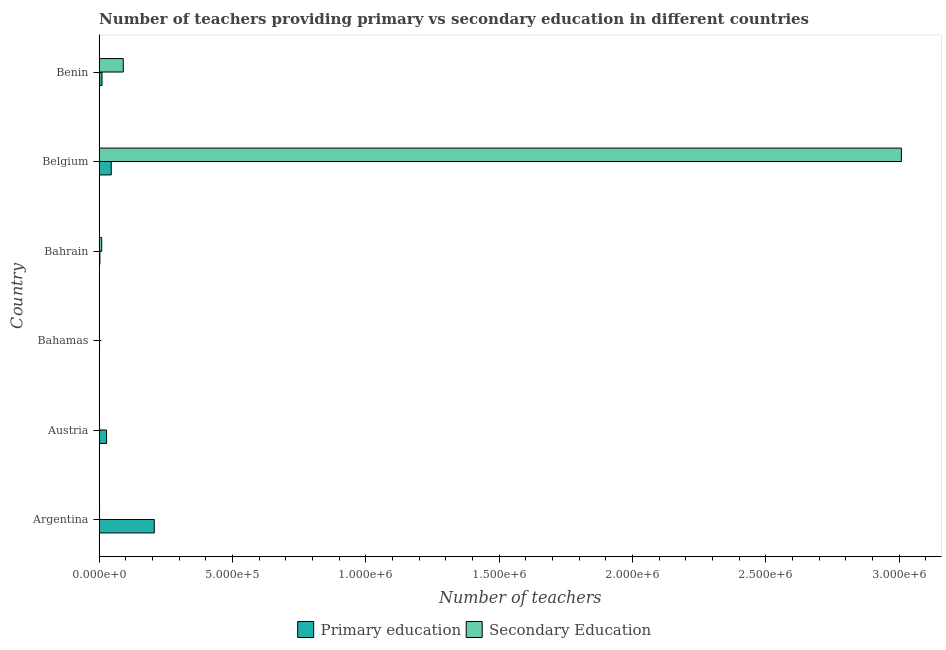How many different coloured bars are there?
Make the answer very short. 2. How many bars are there on the 2nd tick from the top?
Keep it short and to the point. 2. In how many cases, is the number of bars for a given country not equal to the number of legend labels?
Keep it short and to the point. 0. What is the number of secondary teachers in Bahrain?
Make the answer very short. 9335. Across all countries, what is the maximum number of primary teachers?
Keep it short and to the point. 2.07e+05. Across all countries, what is the minimum number of secondary teachers?
Your response must be concise. 210. In which country was the number of primary teachers maximum?
Ensure brevity in your answer.  Argentina. In which country was the number of secondary teachers minimum?
Your answer should be compact. Bahamas. What is the total number of primary teachers in the graph?
Ensure brevity in your answer.  2.93e+05. What is the difference between the number of primary teachers in Argentina and that in Bahamas?
Give a very brief answer. 2.05e+05. What is the difference between the number of secondary teachers in Argentina and the number of primary teachers in Bahrain?
Offer a terse response. -1312. What is the average number of secondary teachers per country?
Your answer should be compact. 5.18e+05. What is the difference between the number of secondary teachers and number of primary teachers in Argentina?
Give a very brief answer. -2.05e+05. What is the ratio of the number of primary teachers in Argentina to that in Bahamas?
Ensure brevity in your answer.  179.44. Is the difference between the number of secondary teachers in Bahamas and Bahrain greater than the difference between the number of primary teachers in Bahamas and Bahrain?
Make the answer very short. No. What is the difference between the highest and the second highest number of secondary teachers?
Your answer should be compact. 2.92e+06. What is the difference between the highest and the lowest number of primary teachers?
Ensure brevity in your answer.  2.05e+05. In how many countries, is the number of primary teachers greater than the average number of primary teachers taken over all countries?
Provide a short and direct response. 1. Is the sum of the number of secondary teachers in Austria and Benin greater than the maximum number of primary teachers across all countries?
Your response must be concise. No. What does the 1st bar from the top in Bahamas represents?
Provide a succinct answer. Secondary Education. How many bars are there?
Keep it short and to the point. 12. Are all the bars in the graph horizontal?
Provide a short and direct response. Yes. How many countries are there in the graph?
Offer a terse response. 6. What is the difference between two consecutive major ticks on the X-axis?
Your answer should be very brief. 5.00e+05. Does the graph contain any zero values?
Offer a terse response. No. Does the graph contain grids?
Your response must be concise. No. How are the legend labels stacked?
Your response must be concise. Horizontal. What is the title of the graph?
Give a very brief answer. Number of teachers providing primary vs secondary education in different countries. Does "Foreign Liabilities" appear as one of the legend labels in the graph?
Offer a terse response. No. What is the label or title of the X-axis?
Ensure brevity in your answer.  Number of teachers. What is the label or title of the Y-axis?
Keep it short and to the point. Country. What is the Number of teachers of Primary education in Argentina?
Make the answer very short. 2.07e+05. What is the Number of teachers in Secondary Education in Argentina?
Give a very brief answer. 1231. What is the Number of teachers of Primary education in Austria?
Your answer should be very brief. 2.76e+04. What is the Number of teachers in Secondary Education in Austria?
Make the answer very short. 1155. What is the Number of teachers in Primary education in Bahamas?
Provide a succinct answer. 1151. What is the Number of teachers in Secondary Education in Bahamas?
Your answer should be compact. 210. What is the Number of teachers in Primary education in Bahrain?
Offer a very short reply. 2543. What is the Number of teachers of Secondary Education in Bahrain?
Provide a succinct answer. 9335. What is the Number of teachers of Primary education in Belgium?
Keep it short and to the point. 4.51e+04. What is the Number of teachers in Secondary Education in Belgium?
Provide a succinct answer. 3.01e+06. What is the Number of teachers of Primary education in Benin?
Provide a succinct answer. 1.04e+04. What is the Number of teachers of Secondary Education in Benin?
Provide a succinct answer. 9.02e+04. Across all countries, what is the maximum Number of teachers of Primary education?
Keep it short and to the point. 2.07e+05. Across all countries, what is the maximum Number of teachers in Secondary Education?
Your answer should be compact. 3.01e+06. Across all countries, what is the minimum Number of teachers of Primary education?
Your response must be concise. 1151. Across all countries, what is the minimum Number of teachers in Secondary Education?
Your answer should be very brief. 210. What is the total Number of teachers of Primary education in the graph?
Keep it short and to the point. 2.93e+05. What is the total Number of teachers of Secondary Education in the graph?
Provide a short and direct response. 3.11e+06. What is the difference between the Number of teachers of Primary education in Argentina and that in Austria?
Your answer should be very brief. 1.79e+05. What is the difference between the Number of teachers in Primary education in Argentina and that in Bahamas?
Provide a succinct answer. 2.05e+05. What is the difference between the Number of teachers of Secondary Education in Argentina and that in Bahamas?
Your response must be concise. 1021. What is the difference between the Number of teachers in Primary education in Argentina and that in Bahrain?
Keep it short and to the point. 2.04e+05. What is the difference between the Number of teachers in Secondary Education in Argentina and that in Bahrain?
Make the answer very short. -8104. What is the difference between the Number of teachers in Primary education in Argentina and that in Belgium?
Offer a very short reply. 1.61e+05. What is the difference between the Number of teachers in Secondary Education in Argentina and that in Belgium?
Keep it short and to the point. -3.01e+06. What is the difference between the Number of teachers in Primary education in Argentina and that in Benin?
Your answer should be very brief. 1.96e+05. What is the difference between the Number of teachers in Secondary Education in Argentina and that in Benin?
Offer a very short reply. -8.89e+04. What is the difference between the Number of teachers in Primary education in Austria and that in Bahamas?
Provide a short and direct response. 2.64e+04. What is the difference between the Number of teachers of Secondary Education in Austria and that in Bahamas?
Offer a terse response. 945. What is the difference between the Number of teachers of Primary education in Austria and that in Bahrain?
Your answer should be compact. 2.50e+04. What is the difference between the Number of teachers of Secondary Education in Austria and that in Bahrain?
Ensure brevity in your answer.  -8180. What is the difference between the Number of teachers of Primary education in Austria and that in Belgium?
Your answer should be very brief. -1.76e+04. What is the difference between the Number of teachers in Secondary Education in Austria and that in Belgium?
Provide a short and direct response. -3.01e+06. What is the difference between the Number of teachers in Primary education in Austria and that in Benin?
Your response must be concise. 1.72e+04. What is the difference between the Number of teachers of Secondary Education in Austria and that in Benin?
Your answer should be very brief. -8.90e+04. What is the difference between the Number of teachers of Primary education in Bahamas and that in Bahrain?
Ensure brevity in your answer.  -1392. What is the difference between the Number of teachers of Secondary Education in Bahamas and that in Bahrain?
Offer a terse response. -9125. What is the difference between the Number of teachers in Primary education in Bahamas and that in Belgium?
Your answer should be compact. -4.40e+04. What is the difference between the Number of teachers in Secondary Education in Bahamas and that in Belgium?
Provide a succinct answer. -3.01e+06. What is the difference between the Number of teachers of Primary education in Bahamas and that in Benin?
Provide a short and direct response. -9230. What is the difference between the Number of teachers of Secondary Education in Bahamas and that in Benin?
Make the answer very short. -9.00e+04. What is the difference between the Number of teachers in Primary education in Bahrain and that in Belgium?
Give a very brief answer. -4.26e+04. What is the difference between the Number of teachers of Secondary Education in Bahrain and that in Belgium?
Make the answer very short. -3.00e+06. What is the difference between the Number of teachers of Primary education in Bahrain and that in Benin?
Give a very brief answer. -7838. What is the difference between the Number of teachers of Secondary Education in Bahrain and that in Benin?
Give a very brief answer. -8.08e+04. What is the difference between the Number of teachers in Primary education in Belgium and that in Benin?
Your response must be concise. 3.47e+04. What is the difference between the Number of teachers in Secondary Education in Belgium and that in Benin?
Your answer should be compact. 2.92e+06. What is the difference between the Number of teachers of Primary education in Argentina and the Number of teachers of Secondary Education in Austria?
Give a very brief answer. 2.05e+05. What is the difference between the Number of teachers in Primary education in Argentina and the Number of teachers in Secondary Education in Bahamas?
Your answer should be compact. 2.06e+05. What is the difference between the Number of teachers of Primary education in Argentina and the Number of teachers of Secondary Education in Bahrain?
Keep it short and to the point. 1.97e+05. What is the difference between the Number of teachers in Primary education in Argentina and the Number of teachers in Secondary Education in Belgium?
Make the answer very short. -2.80e+06. What is the difference between the Number of teachers of Primary education in Argentina and the Number of teachers of Secondary Education in Benin?
Provide a succinct answer. 1.16e+05. What is the difference between the Number of teachers in Primary education in Austria and the Number of teachers in Secondary Education in Bahamas?
Your answer should be very brief. 2.74e+04. What is the difference between the Number of teachers of Primary education in Austria and the Number of teachers of Secondary Education in Bahrain?
Offer a very short reply. 1.82e+04. What is the difference between the Number of teachers of Primary education in Austria and the Number of teachers of Secondary Education in Belgium?
Offer a very short reply. -2.98e+06. What is the difference between the Number of teachers in Primary education in Austria and the Number of teachers in Secondary Education in Benin?
Make the answer very short. -6.26e+04. What is the difference between the Number of teachers of Primary education in Bahamas and the Number of teachers of Secondary Education in Bahrain?
Your answer should be compact. -8184. What is the difference between the Number of teachers of Primary education in Bahamas and the Number of teachers of Secondary Education in Belgium?
Make the answer very short. -3.01e+06. What is the difference between the Number of teachers of Primary education in Bahamas and the Number of teachers of Secondary Education in Benin?
Your answer should be compact. -8.90e+04. What is the difference between the Number of teachers in Primary education in Bahrain and the Number of teachers in Secondary Education in Belgium?
Offer a very short reply. -3.01e+06. What is the difference between the Number of teachers in Primary education in Bahrain and the Number of teachers in Secondary Education in Benin?
Make the answer very short. -8.76e+04. What is the difference between the Number of teachers of Primary education in Belgium and the Number of teachers of Secondary Education in Benin?
Your response must be concise. -4.50e+04. What is the average Number of teachers of Primary education per country?
Ensure brevity in your answer.  4.89e+04. What is the average Number of teachers of Secondary Education per country?
Offer a terse response. 5.18e+05. What is the difference between the Number of teachers in Primary education and Number of teachers in Secondary Education in Argentina?
Provide a short and direct response. 2.05e+05. What is the difference between the Number of teachers in Primary education and Number of teachers in Secondary Education in Austria?
Give a very brief answer. 2.64e+04. What is the difference between the Number of teachers of Primary education and Number of teachers of Secondary Education in Bahamas?
Offer a very short reply. 941. What is the difference between the Number of teachers of Primary education and Number of teachers of Secondary Education in Bahrain?
Provide a succinct answer. -6792. What is the difference between the Number of teachers in Primary education and Number of teachers in Secondary Education in Belgium?
Provide a succinct answer. -2.96e+06. What is the difference between the Number of teachers of Primary education and Number of teachers of Secondary Education in Benin?
Provide a short and direct response. -7.98e+04. What is the ratio of the Number of teachers of Primary education in Argentina to that in Austria?
Your response must be concise. 7.49. What is the ratio of the Number of teachers in Secondary Education in Argentina to that in Austria?
Provide a succinct answer. 1.07. What is the ratio of the Number of teachers of Primary education in Argentina to that in Bahamas?
Keep it short and to the point. 179.44. What is the ratio of the Number of teachers in Secondary Education in Argentina to that in Bahamas?
Offer a terse response. 5.86. What is the ratio of the Number of teachers of Primary education in Argentina to that in Bahrain?
Ensure brevity in your answer.  81.22. What is the ratio of the Number of teachers in Secondary Education in Argentina to that in Bahrain?
Make the answer very short. 0.13. What is the ratio of the Number of teachers in Primary education in Argentina to that in Belgium?
Give a very brief answer. 4.58. What is the ratio of the Number of teachers of Secondary Education in Argentina to that in Belgium?
Provide a succinct answer. 0. What is the ratio of the Number of teachers in Primary education in Argentina to that in Benin?
Keep it short and to the point. 19.9. What is the ratio of the Number of teachers of Secondary Education in Argentina to that in Benin?
Your answer should be very brief. 0.01. What is the ratio of the Number of teachers of Primary education in Austria to that in Bahamas?
Provide a succinct answer. 23.95. What is the ratio of the Number of teachers of Primary education in Austria to that in Bahrain?
Keep it short and to the point. 10.84. What is the ratio of the Number of teachers in Secondary Education in Austria to that in Bahrain?
Make the answer very short. 0.12. What is the ratio of the Number of teachers in Primary education in Austria to that in Belgium?
Provide a succinct answer. 0.61. What is the ratio of the Number of teachers of Secondary Education in Austria to that in Belgium?
Provide a short and direct response. 0. What is the ratio of the Number of teachers of Primary education in Austria to that in Benin?
Your answer should be compact. 2.65. What is the ratio of the Number of teachers in Secondary Education in Austria to that in Benin?
Keep it short and to the point. 0.01. What is the ratio of the Number of teachers of Primary education in Bahamas to that in Bahrain?
Offer a terse response. 0.45. What is the ratio of the Number of teachers of Secondary Education in Bahamas to that in Bahrain?
Make the answer very short. 0.02. What is the ratio of the Number of teachers of Primary education in Bahamas to that in Belgium?
Offer a very short reply. 0.03. What is the ratio of the Number of teachers of Secondary Education in Bahamas to that in Belgium?
Offer a very short reply. 0. What is the ratio of the Number of teachers in Primary education in Bahamas to that in Benin?
Ensure brevity in your answer.  0.11. What is the ratio of the Number of teachers of Secondary Education in Bahamas to that in Benin?
Your answer should be compact. 0. What is the ratio of the Number of teachers in Primary education in Bahrain to that in Belgium?
Give a very brief answer. 0.06. What is the ratio of the Number of teachers in Secondary Education in Bahrain to that in Belgium?
Your answer should be compact. 0. What is the ratio of the Number of teachers of Primary education in Bahrain to that in Benin?
Your response must be concise. 0.24. What is the ratio of the Number of teachers of Secondary Education in Bahrain to that in Benin?
Keep it short and to the point. 0.1. What is the ratio of the Number of teachers of Primary education in Belgium to that in Benin?
Your answer should be compact. 4.35. What is the ratio of the Number of teachers of Secondary Education in Belgium to that in Benin?
Your answer should be very brief. 33.37. What is the difference between the highest and the second highest Number of teachers of Primary education?
Provide a short and direct response. 1.61e+05. What is the difference between the highest and the second highest Number of teachers of Secondary Education?
Keep it short and to the point. 2.92e+06. What is the difference between the highest and the lowest Number of teachers of Primary education?
Offer a very short reply. 2.05e+05. What is the difference between the highest and the lowest Number of teachers of Secondary Education?
Offer a terse response. 3.01e+06. 